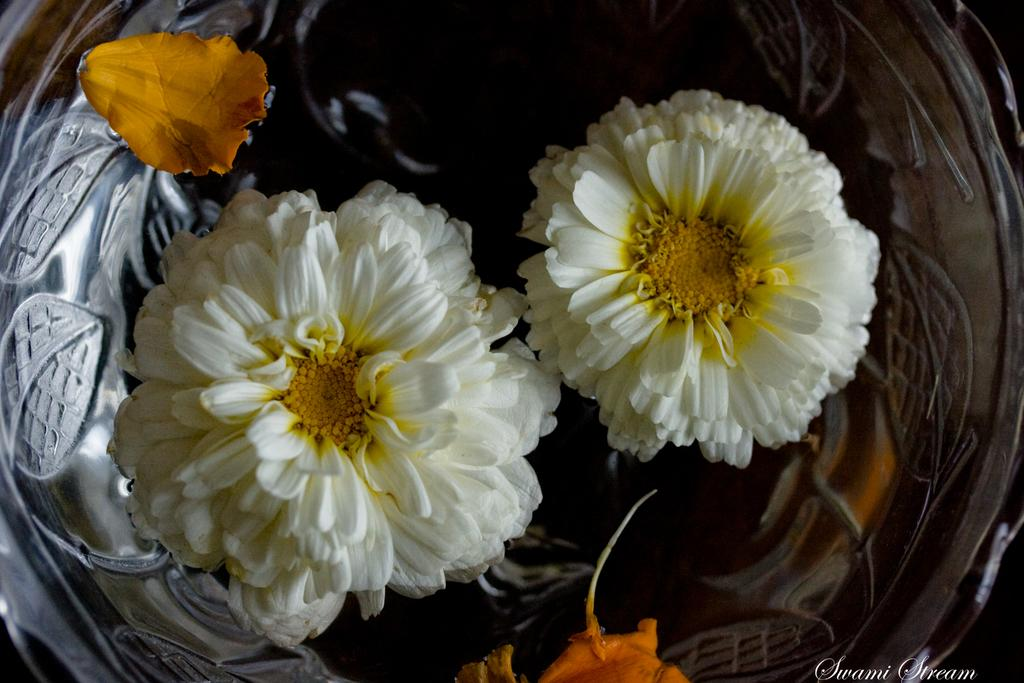What is in the image that contains something? There is a bowl in the image. What is inside the bowl? The bowl contains flowers. How many times has the watch been folded in the image? There is no watch present in the image, so it cannot be folded. 